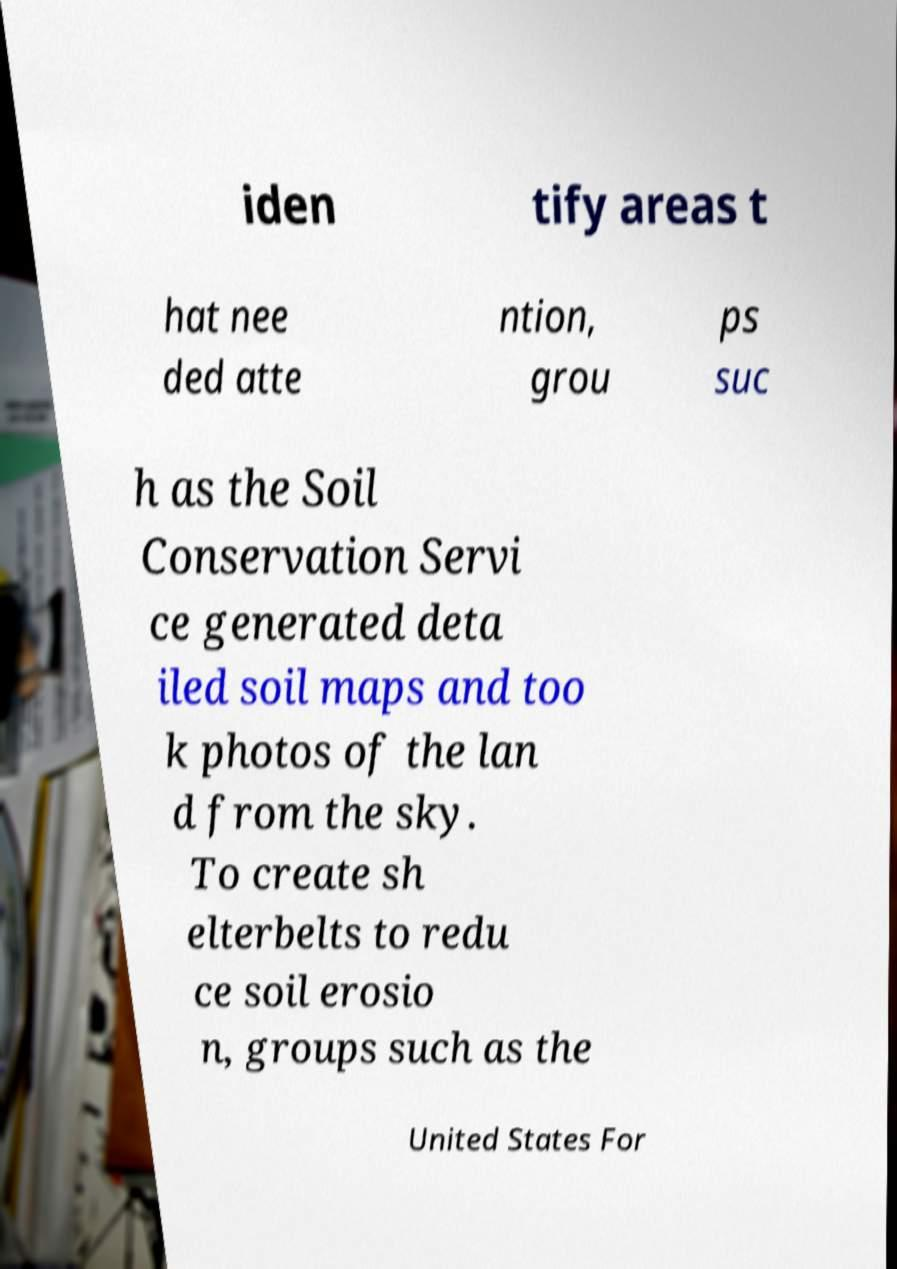What messages or text are displayed in this image? I need them in a readable, typed format. iden tify areas t hat nee ded atte ntion, grou ps suc h as the Soil Conservation Servi ce generated deta iled soil maps and too k photos of the lan d from the sky. To create sh elterbelts to redu ce soil erosio n, groups such as the United States For 